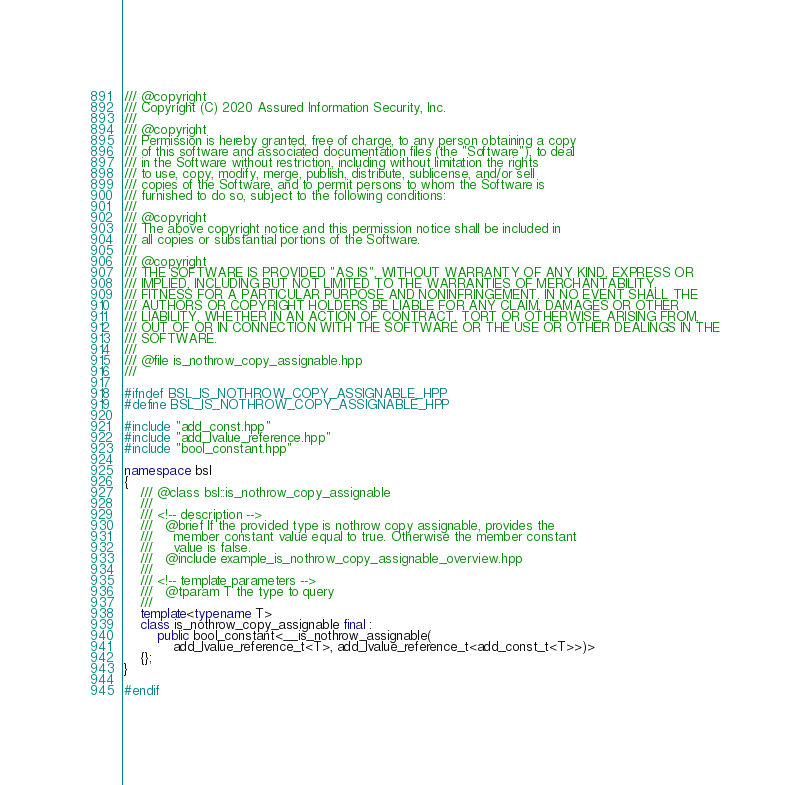<code> <loc_0><loc_0><loc_500><loc_500><_C++_>/// @copyright
/// Copyright (C) 2020 Assured Information Security, Inc.
///
/// @copyright
/// Permission is hereby granted, free of charge, to any person obtaining a copy
/// of this software and associated documentation files (the "Software"), to deal
/// in the Software without restriction, including without limitation the rights
/// to use, copy, modify, merge, publish, distribute, sublicense, and/or sell
/// copies of the Software, and to permit persons to whom the Software is
/// furnished to do so, subject to the following conditions:
///
/// @copyright
/// The above copyright notice and this permission notice shall be included in
/// all copies or substantial portions of the Software.
///
/// @copyright
/// THE SOFTWARE IS PROVIDED "AS IS", WITHOUT WARRANTY OF ANY KIND, EXPRESS OR
/// IMPLIED, INCLUDING BUT NOT LIMITED TO THE WARRANTIES OF MERCHANTABILITY,
/// FITNESS FOR A PARTICULAR PURPOSE AND NONINFRINGEMENT. IN NO EVENT SHALL THE
/// AUTHORS OR COPYRIGHT HOLDERS BE LIABLE FOR ANY CLAIM, DAMAGES OR OTHER
/// LIABILITY, WHETHER IN AN ACTION OF CONTRACT, TORT OR OTHERWISE, ARISING FROM,
/// OUT OF OR IN CONNECTION WITH THE SOFTWARE OR THE USE OR OTHER DEALINGS IN THE
/// SOFTWARE.
///
/// @file is_nothrow_copy_assignable.hpp
///

#ifndef BSL_IS_NOTHROW_COPY_ASSIGNABLE_HPP
#define BSL_IS_NOTHROW_COPY_ASSIGNABLE_HPP

#include "add_const.hpp"
#include "add_lvalue_reference.hpp"
#include "bool_constant.hpp"

namespace bsl
{
    /// @class bsl::is_nothrow_copy_assignable
    ///
    /// <!-- description -->
    ///   @brief If the provided type is nothrow copy assignable, provides the
    ///     member constant value equal to true. Otherwise the member constant
    ///     value is false.
    ///   @include example_is_nothrow_copy_assignable_overview.hpp
    ///
    /// <!-- template parameters -->
    ///   @tparam T the type to query
    ///
    template<typename T>
    class is_nothrow_copy_assignable final :
        public bool_constant<__is_nothrow_assignable(
            add_lvalue_reference_t<T>, add_lvalue_reference_t<add_const_t<T>>)>
    {};
}

#endif
</code> 